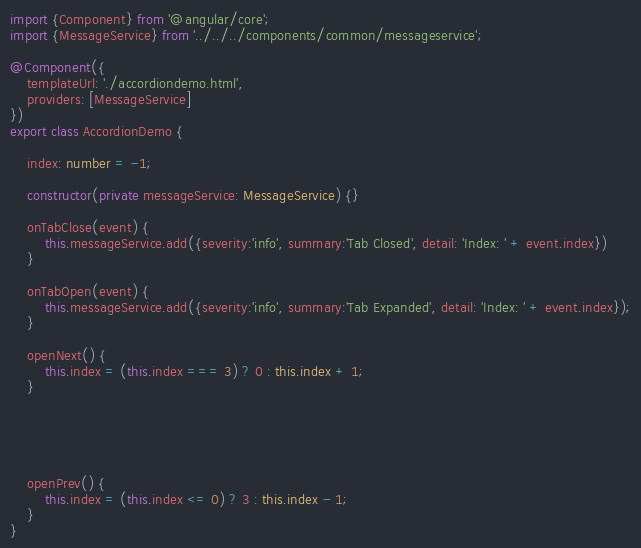<code> <loc_0><loc_0><loc_500><loc_500><_TypeScript_>import {Component} from '@angular/core';
import {MessageService} from '../../../components/common/messageservice';

@Component({
    templateUrl: './accordiondemo.html',
    providers: [MessageService]
})
export class AccordionDemo {
    
    index: number = -1;

    constructor(private messageService: MessageService) {}

    onTabClose(event) {
        this.messageService.add({severity:'info', summary:'Tab Closed', detail: 'Index: ' + event.index})
    }
    
    onTabOpen(event) {
        this.messageService.add({severity:'info', summary:'Tab Expanded', detail: 'Index: ' + event.index});
    }
    
    openNext() {
        this.index = (this.index === 3) ? 0 : this.index + 1;
    }





    openPrev() {
        this.index = (this.index <= 0) ? 3 : this.index - 1;
    }
}
</code> 